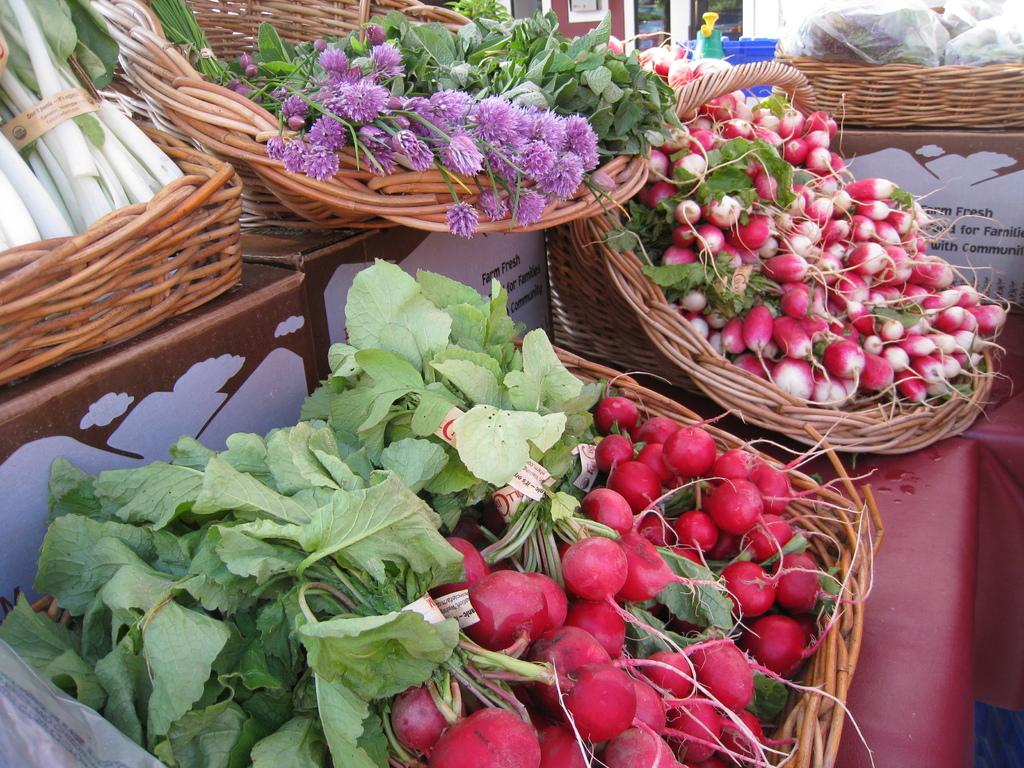What type of food is present on the trays in the image? There are vegetables on trays in the image. What other items can be seen in the image besides the vegetables? There are cardboard boxes in the image. Can you describe the objects visible in the background of the image? Unfortunately, the provided facts do not give enough information to describe the objects in the background. What song is being played by the brass instruments in the image? There are no brass instruments or songs present in the image; it features vegetables on trays and cardboard boxes. Who is the owner of the vegetables in the image? The provided facts do not give any information about the ownership of the vegetables, so it cannot be determined from the image. 